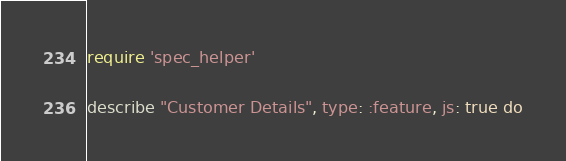<code> <loc_0><loc_0><loc_500><loc_500><_Ruby_>require 'spec_helper'

describe "Customer Details", type: :feature, js: true do</code> 